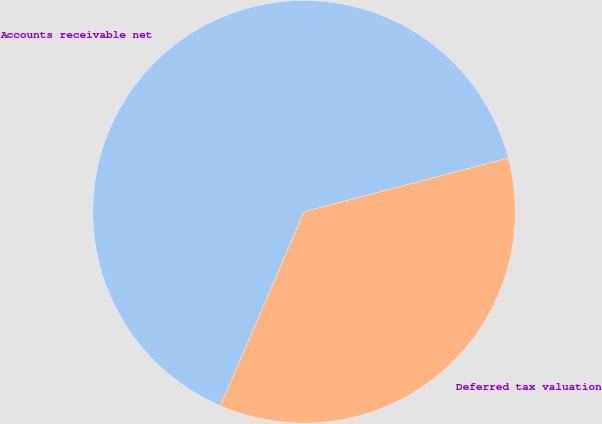<chart> <loc_0><loc_0><loc_500><loc_500><pie_chart><fcel>Accounts receivable net<fcel>Deferred tax valuation<nl><fcel>64.43%<fcel>35.57%<nl></chart> 